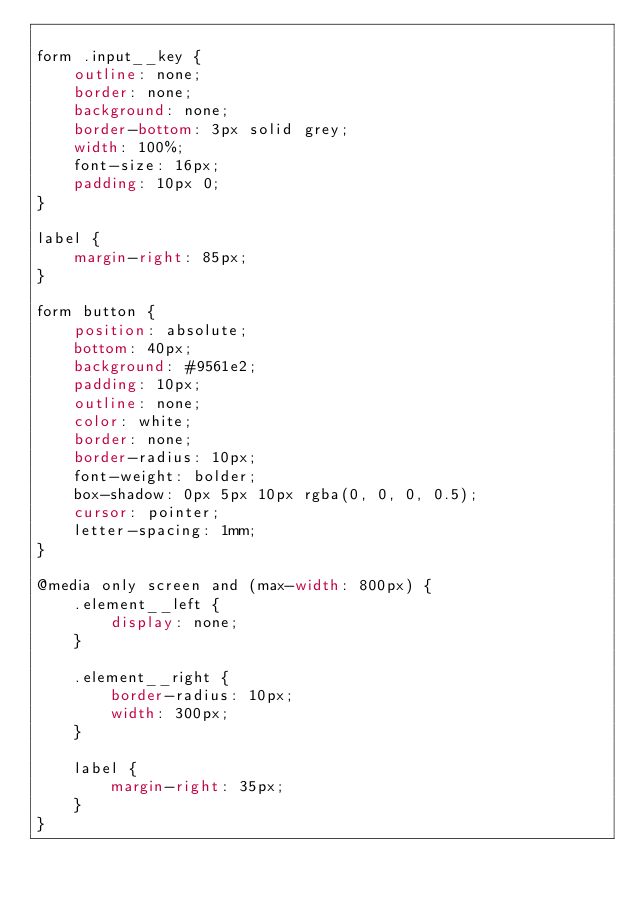Convert code to text. <code><loc_0><loc_0><loc_500><loc_500><_CSS_>
form .input__key {
    outline: none;
    border: none;
    background: none;
    border-bottom: 3px solid grey;
    width: 100%;
    font-size: 16px;
    padding: 10px 0;
}

label {
    margin-right: 85px;
}

form button {
    position: absolute;
    bottom: 40px;
    background: #9561e2;
    padding: 10px;
    outline: none;
    color: white;
    border: none;
    border-radius: 10px;
    font-weight: bolder;
    box-shadow: 0px 5px 10px rgba(0, 0, 0, 0.5);
    cursor: pointer;
    letter-spacing: 1mm;
}

@media only screen and (max-width: 800px) {
    .element__left {
        display: none;
    }

    .element__right {
        border-radius: 10px;
        width: 300px;
    }

    label {
        margin-right: 35px;
    }
}
</code> 